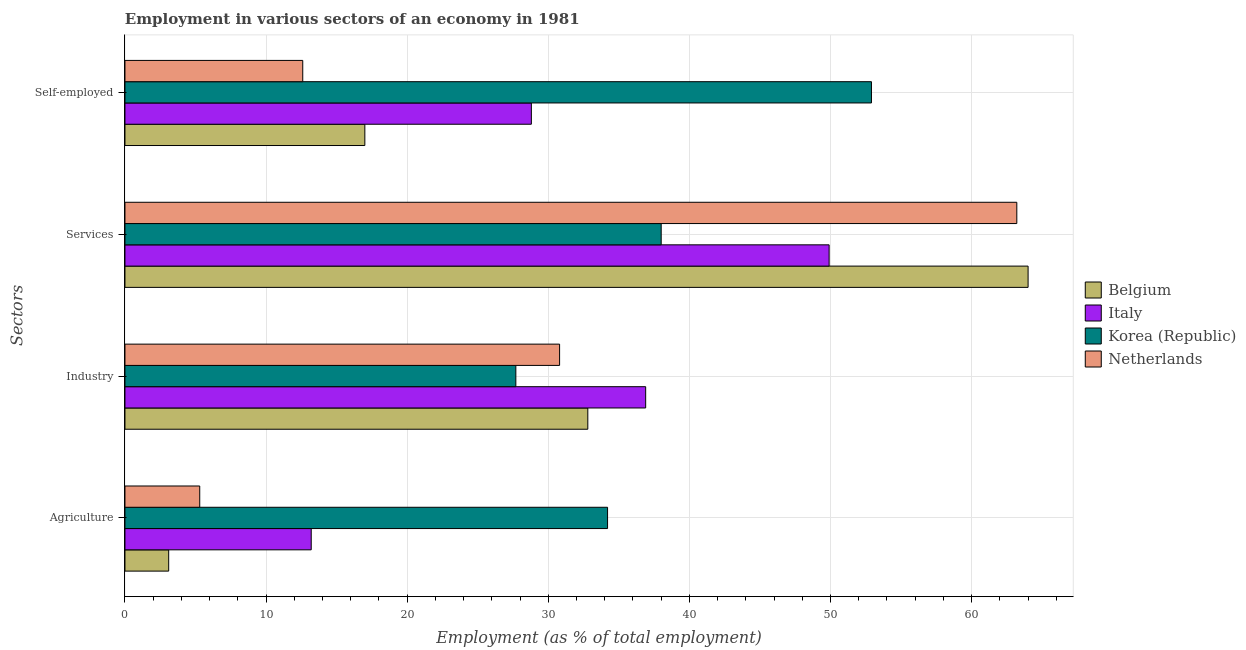How many groups of bars are there?
Offer a terse response. 4. Are the number of bars per tick equal to the number of legend labels?
Provide a succinct answer. Yes. Are the number of bars on each tick of the Y-axis equal?
Make the answer very short. Yes. How many bars are there on the 3rd tick from the bottom?
Offer a terse response. 4. What is the label of the 1st group of bars from the top?
Ensure brevity in your answer.  Self-employed. What is the percentage of workers in services in Italy?
Offer a very short reply. 49.9. Across all countries, what is the maximum percentage of workers in industry?
Your answer should be compact. 36.9. Across all countries, what is the minimum percentage of workers in agriculture?
Your answer should be very brief. 3.1. In which country was the percentage of workers in industry maximum?
Ensure brevity in your answer.  Italy. In which country was the percentage of workers in services minimum?
Provide a short and direct response. Korea (Republic). What is the total percentage of workers in services in the graph?
Offer a terse response. 215.1. What is the difference between the percentage of workers in industry in Belgium and that in Korea (Republic)?
Offer a terse response. 5.1. What is the difference between the percentage of workers in agriculture in Netherlands and the percentage of workers in services in Belgium?
Provide a succinct answer. -58.7. What is the average percentage of workers in agriculture per country?
Offer a terse response. 13.95. What is the difference between the percentage of workers in agriculture and percentage of workers in industry in Italy?
Offer a very short reply. -23.7. What is the ratio of the percentage of workers in industry in Netherlands to that in Korea (Republic)?
Provide a succinct answer. 1.11. Is the percentage of workers in industry in Netherlands less than that in Belgium?
Your answer should be compact. Yes. What is the difference between the highest and the second highest percentage of workers in services?
Provide a short and direct response. 0.8. What is the difference between the highest and the lowest percentage of workers in industry?
Provide a short and direct response. 9.2. Does the graph contain any zero values?
Your answer should be compact. No. Where does the legend appear in the graph?
Your answer should be very brief. Center right. How many legend labels are there?
Keep it short and to the point. 4. What is the title of the graph?
Offer a very short reply. Employment in various sectors of an economy in 1981. What is the label or title of the X-axis?
Your response must be concise. Employment (as % of total employment). What is the label or title of the Y-axis?
Keep it short and to the point. Sectors. What is the Employment (as % of total employment) of Belgium in Agriculture?
Give a very brief answer. 3.1. What is the Employment (as % of total employment) of Italy in Agriculture?
Offer a very short reply. 13.2. What is the Employment (as % of total employment) in Korea (Republic) in Agriculture?
Provide a succinct answer. 34.2. What is the Employment (as % of total employment) in Netherlands in Agriculture?
Give a very brief answer. 5.3. What is the Employment (as % of total employment) of Belgium in Industry?
Keep it short and to the point. 32.8. What is the Employment (as % of total employment) in Italy in Industry?
Your answer should be very brief. 36.9. What is the Employment (as % of total employment) in Korea (Republic) in Industry?
Offer a terse response. 27.7. What is the Employment (as % of total employment) of Netherlands in Industry?
Your answer should be very brief. 30.8. What is the Employment (as % of total employment) in Italy in Services?
Your response must be concise. 49.9. What is the Employment (as % of total employment) in Netherlands in Services?
Offer a terse response. 63.2. What is the Employment (as % of total employment) of Belgium in Self-employed?
Give a very brief answer. 17. What is the Employment (as % of total employment) of Italy in Self-employed?
Provide a succinct answer. 28.8. What is the Employment (as % of total employment) of Korea (Republic) in Self-employed?
Keep it short and to the point. 52.9. What is the Employment (as % of total employment) of Netherlands in Self-employed?
Your response must be concise. 12.6. Across all Sectors, what is the maximum Employment (as % of total employment) in Italy?
Give a very brief answer. 49.9. Across all Sectors, what is the maximum Employment (as % of total employment) in Korea (Republic)?
Your answer should be compact. 52.9. Across all Sectors, what is the maximum Employment (as % of total employment) in Netherlands?
Your response must be concise. 63.2. Across all Sectors, what is the minimum Employment (as % of total employment) in Belgium?
Your answer should be very brief. 3.1. Across all Sectors, what is the minimum Employment (as % of total employment) of Italy?
Your response must be concise. 13.2. Across all Sectors, what is the minimum Employment (as % of total employment) in Korea (Republic)?
Your answer should be compact. 27.7. Across all Sectors, what is the minimum Employment (as % of total employment) of Netherlands?
Ensure brevity in your answer.  5.3. What is the total Employment (as % of total employment) in Belgium in the graph?
Keep it short and to the point. 116.9. What is the total Employment (as % of total employment) of Italy in the graph?
Offer a terse response. 128.8. What is the total Employment (as % of total employment) of Korea (Republic) in the graph?
Your response must be concise. 152.8. What is the total Employment (as % of total employment) in Netherlands in the graph?
Provide a short and direct response. 111.9. What is the difference between the Employment (as % of total employment) in Belgium in Agriculture and that in Industry?
Provide a short and direct response. -29.7. What is the difference between the Employment (as % of total employment) of Italy in Agriculture and that in Industry?
Ensure brevity in your answer.  -23.7. What is the difference between the Employment (as % of total employment) of Korea (Republic) in Agriculture and that in Industry?
Your answer should be compact. 6.5. What is the difference between the Employment (as % of total employment) in Netherlands in Agriculture and that in Industry?
Keep it short and to the point. -25.5. What is the difference between the Employment (as % of total employment) in Belgium in Agriculture and that in Services?
Keep it short and to the point. -60.9. What is the difference between the Employment (as % of total employment) of Italy in Agriculture and that in Services?
Give a very brief answer. -36.7. What is the difference between the Employment (as % of total employment) in Netherlands in Agriculture and that in Services?
Make the answer very short. -57.9. What is the difference between the Employment (as % of total employment) of Belgium in Agriculture and that in Self-employed?
Your response must be concise. -13.9. What is the difference between the Employment (as % of total employment) in Italy in Agriculture and that in Self-employed?
Make the answer very short. -15.6. What is the difference between the Employment (as % of total employment) in Korea (Republic) in Agriculture and that in Self-employed?
Keep it short and to the point. -18.7. What is the difference between the Employment (as % of total employment) of Belgium in Industry and that in Services?
Provide a succinct answer. -31.2. What is the difference between the Employment (as % of total employment) in Italy in Industry and that in Services?
Keep it short and to the point. -13. What is the difference between the Employment (as % of total employment) in Netherlands in Industry and that in Services?
Ensure brevity in your answer.  -32.4. What is the difference between the Employment (as % of total employment) in Belgium in Industry and that in Self-employed?
Give a very brief answer. 15.8. What is the difference between the Employment (as % of total employment) in Italy in Industry and that in Self-employed?
Give a very brief answer. 8.1. What is the difference between the Employment (as % of total employment) in Korea (Republic) in Industry and that in Self-employed?
Offer a terse response. -25.2. What is the difference between the Employment (as % of total employment) of Netherlands in Industry and that in Self-employed?
Offer a very short reply. 18.2. What is the difference between the Employment (as % of total employment) of Italy in Services and that in Self-employed?
Your answer should be very brief. 21.1. What is the difference between the Employment (as % of total employment) in Korea (Republic) in Services and that in Self-employed?
Ensure brevity in your answer.  -14.9. What is the difference between the Employment (as % of total employment) in Netherlands in Services and that in Self-employed?
Provide a short and direct response. 50.6. What is the difference between the Employment (as % of total employment) of Belgium in Agriculture and the Employment (as % of total employment) of Italy in Industry?
Offer a very short reply. -33.8. What is the difference between the Employment (as % of total employment) in Belgium in Agriculture and the Employment (as % of total employment) in Korea (Republic) in Industry?
Make the answer very short. -24.6. What is the difference between the Employment (as % of total employment) in Belgium in Agriculture and the Employment (as % of total employment) in Netherlands in Industry?
Ensure brevity in your answer.  -27.7. What is the difference between the Employment (as % of total employment) of Italy in Agriculture and the Employment (as % of total employment) of Netherlands in Industry?
Your answer should be very brief. -17.6. What is the difference between the Employment (as % of total employment) in Korea (Republic) in Agriculture and the Employment (as % of total employment) in Netherlands in Industry?
Your response must be concise. 3.4. What is the difference between the Employment (as % of total employment) in Belgium in Agriculture and the Employment (as % of total employment) in Italy in Services?
Your response must be concise. -46.8. What is the difference between the Employment (as % of total employment) of Belgium in Agriculture and the Employment (as % of total employment) of Korea (Republic) in Services?
Your response must be concise. -34.9. What is the difference between the Employment (as % of total employment) in Belgium in Agriculture and the Employment (as % of total employment) in Netherlands in Services?
Offer a very short reply. -60.1. What is the difference between the Employment (as % of total employment) of Italy in Agriculture and the Employment (as % of total employment) of Korea (Republic) in Services?
Your response must be concise. -24.8. What is the difference between the Employment (as % of total employment) of Belgium in Agriculture and the Employment (as % of total employment) of Italy in Self-employed?
Provide a succinct answer. -25.7. What is the difference between the Employment (as % of total employment) of Belgium in Agriculture and the Employment (as % of total employment) of Korea (Republic) in Self-employed?
Offer a terse response. -49.8. What is the difference between the Employment (as % of total employment) of Italy in Agriculture and the Employment (as % of total employment) of Korea (Republic) in Self-employed?
Your response must be concise. -39.7. What is the difference between the Employment (as % of total employment) in Italy in Agriculture and the Employment (as % of total employment) in Netherlands in Self-employed?
Offer a terse response. 0.6. What is the difference between the Employment (as % of total employment) in Korea (Republic) in Agriculture and the Employment (as % of total employment) in Netherlands in Self-employed?
Your response must be concise. 21.6. What is the difference between the Employment (as % of total employment) in Belgium in Industry and the Employment (as % of total employment) in Italy in Services?
Your response must be concise. -17.1. What is the difference between the Employment (as % of total employment) in Belgium in Industry and the Employment (as % of total employment) in Korea (Republic) in Services?
Ensure brevity in your answer.  -5.2. What is the difference between the Employment (as % of total employment) of Belgium in Industry and the Employment (as % of total employment) of Netherlands in Services?
Ensure brevity in your answer.  -30.4. What is the difference between the Employment (as % of total employment) of Italy in Industry and the Employment (as % of total employment) of Korea (Republic) in Services?
Your answer should be very brief. -1.1. What is the difference between the Employment (as % of total employment) of Italy in Industry and the Employment (as % of total employment) of Netherlands in Services?
Provide a succinct answer. -26.3. What is the difference between the Employment (as % of total employment) in Korea (Republic) in Industry and the Employment (as % of total employment) in Netherlands in Services?
Your response must be concise. -35.5. What is the difference between the Employment (as % of total employment) in Belgium in Industry and the Employment (as % of total employment) in Korea (Republic) in Self-employed?
Your answer should be compact. -20.1. What is the difference between the Employment (as % of total employment) of Belgium in Industry and the Employment (as % of total employment) of Netherlands in Self-employed?
Your answer should be compact. 20.2. What is the difference between the Employment (as % of total employment) in Italy in Industry and the Employment (as % of total employment) in Korea (Republic) in Self-employed?
Provide a succinct answer. -16. What is the difference between the Employment (as % of total employment) of Italy in Industry and the Employment (as % of total employment) of Netherlands in Self-employed?
Your response must be concise. 24.3. What is the difference between the Employment (as % of total employment) in Belgium in Services and the Employment (as % of total employment) in Italy in Self-employed?
Offer a very short reply. 35.2. What is the difference between the Employment (as % of total employment) of Belgium in Services and the Employment (as % of total employment) of Netherlands in Self-employed?
Provide a short and direct response. 51.4. What is the difference between the Employment (as % of total employment) of Italy in Services and the Employment (as % of total employment) of Korea (Republic) in Self-employed?
Your response must be concise. -3. What is the difference between the Employment (as % of total employment) of Italy in Services and the Employment (as % of total employment) of Netherlands in Self-employed?
Ensure brevity in your answer.  37.3. What is the difference between the Employment (as % of total employment) in Korea (Republic) in Services and the Employment (as % of total employment) in Netherlands in Self-employed?
Your answer should be compact. 25.4. What is the average Employment (as % of total employment) in Belgium per Sectors?
Keep it short and to the point. 29.23. What is the average Employment (as % of total employment) in Italy per Sectors?
Provide a short and direct response. 32.2. What is the average Employment (as % of total employment) of Korea (Republic) per Sectors?
Your response must be concise. 38.2. What is the average Employment (as % of total employment) of Netherlands per Sectors?
Your answer should be very brief. 27.98. What is the difference between the Employment (as % of total employment) of Belgium and Employment (as % of total employment) of Korea (Republic) in Agriculture?
Offer a very short reply. -31.1. What is the difference between the Employment (as % of total employment) in Italy and Employment (as % of total employment) in Korea (Republic) in Agriculture?
Your response must be concise. -21. What is the difference between the Employment (as % of total employment) of Italy and Employment (as % of total employment) of Netherlands in Agriculture?
Your answer should be very brief. 7.9. What is the difference between the Employment (as % of total employment) in Korea (Republic) and Employment (as % of total employment) in Netherlands in Agriculture?
Provide a succinct answer. 28.9. What is the difference between the Employment (as % of total employment) of Belgium and Employment (as % of total employment) of Italy in Industry?
Ensure brevity in your answer.  -4.1. What is the difference between the Employment (as % of total employment) in Italy and Employment (as % of total employment) in Korea (Republic) in Industry?
Keep it short and to the point. 9.2. What is the difference between the Employment (as % of total employment) of Italy and Employment (as % of total employment) of Netherlands in Industry?
Provide a succinct answer. 6.1. What is the difference between the Employment (as % of total employment) of Belgium and Employment (as % of total employment) of Korea (Republic) in Services?
Keep it short and to the point. 26. What is the difference between the Employment (as % of total employment) of Italy and Employment (as % of total employment) of Korea (Republic) in Services?
Offer a terse response. 11.9. What is the difference between the Employment (as % of total employment) of Italy and Employment (as % of total employment) of Netherlands in Services?
Provide a succinct answer. -13.3. What is the difference between the Employment (as % of total employment) in Korea (Republic) and Employment (as % of total employment) in Netherlands in Services?
Provide a short and direct response. -25.2. What is the difference between the Employment (as % of total employment) of Belgium and Employment (as % of total employment) of Korea (Republic) in Self-employed?
Your answer should be very brief. -35.9. What is the difference between the Employment (as % of total employment) of Italy and Employment (as % of total employment) of Korea (Republic) in Self-employed?
Your answer should be compact. -24.1. What is the difference between the Employment (as % of total employment) of Korea (Republic) and Employment (as % of total employment) of Netherlands in Self-employed?
Your answer should be very brief. 40.3. What is the ratio of the Employment (as % of total employment) of Belgium in Agriculture to that in Industry?
Make the answer very short. 0.09. What is the ratio of the Employment (as % of total employment) in Italy in Agriculture to that in Industry?
Your answer should be very brief. 0.36. What is the ratio of the Employment (as % of total employment) of Korea (Republic) in Agriculture to that in Industry?
Provide a succinct answer. 1.23. What is the ratio of the Employment (as % of total employment) in Netherlands in Agriculture to that in Industry?
Your response must be concise. 0.17. What is the ratio of the Employment (as % of total employment) in Belgium in Agriculture to that in Services?
Your answer should be very brief. 0.05. What is the ratio of the Employment (as % of total employment) of Italy in Agriculture to that in Services?
Offer a terse response. 0.26. What is the ratio of the Employment (as % of total employment) of Netherlands in Agriculture to that in Services?
Provide a short and direct response. 0.08. What is the ratio of the Employment (as % of total employment) in Belgium in Agriculture to that in Self-employed?
Offer a very short reply. 0.18. What is the ratio of the Employment (as % of total employment) in Italy in Agriculture to that in Self-employed?
Your response must be concise. 0.46. What is the ratio of the Employment (as % of total employment) of Korea (Republic) in Agriculture to that in Self-employed?
Provide a short and direct response. 0.65. What is the ratio of the Employment (as % of total employment) in Netherlands in Agriculture to that in Self-employed?
Your answer should be compact. 0.42. What is the ratio of the Employment (as % of total employment) in Belgium in Industry to that in Services?
Make the answer very short. 0.51. What is the ratio of the Employment (as % of total employment) of Italy in Industry to that in Services?
Give a very brief answer. 0.74. What is the ratio of the Employment (as % of total employment) in Korea (Republic) in Industry to that in Services?
Ensure brevity in your answer.  0.73. What is the ratio of the Employment (as % of total employment) of Netherlands in Industry to that in Services?
Your response must be concise. 0.49. What is the ratio of the Employment (as % of total employment) of Belgium in Industry to that in Self-employed?
Offer a very short reply. 1.93. What is the ratio of the Employment (as % of total employment) in Italy in Industry to that in Self-employed?
Your answer should be compact. 1.28. What is the ratio of the Employment (as % of total employment) in Korea (Republic) in Industry to that in Self-employed?
Your answer should be compact. 0.52. What is the ratio of the Employment (as % of total employment) in Netherlands in Industry to that in Self-employed?
Give a very brief answer. 2.44. What is the ratio of the Employment (as % of total employment) in Belgium in Services to that in Self-employed?
Offer a very short reply. 3.76. What is the ratio of the Employment (as % of total employment) in Italy in Services to that in Self-employed?
Your response must be concise. 1.73. What is the ratio of the Employment (as % of total employment) in Korea (Republic) in Services to that in Self-employed?
Your answer should be compact. 0.72. What is the ratio of the Employment (as % of total employment) of Netherlands in Services to that in Self-employed?
Ensure brevity in your answer.  5.02. What is the difference between the highest and the second highest Employment (as % of total employment) in Belgium?
Offer a terse response. 31.2. What is the difference between the highest and the second highest Employment (as % of total employment) in Italy?
Give a very brief answer. 13. What is the difference between the highest and the second highest Employment (as % of total employment) in Netherlands?
Your answer should be compact. 32.4. What is the difference between the highest and the lowest Employment (as % of total employment) of Belgium?
Ensure brevity in your answer.  60.9. What is the difference between the highest and the lowest Employment (as % of total employment) in Italy?
Offer a very short reply. 36.7. What is the difference between the highest and the lowest Employment (as % of total employment) in Korea (Republic)?
Ensure brevity in your answer.  25.2. What is the difference between the highest and the lowest Employment (as % of total employment) in Netherlands?
Your response must be concise. 57.9. 